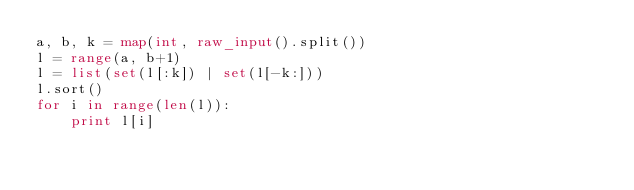<code> <loc_0><loc_0><loc_500><loc_500><_Python_>a, b, k = map(int, raw_input().split())
l = range(a, b+1)
l = list(set(l[:k]) | set(l[-k:]))
l.sort()
for i in range(len(l)):
	print l[i]</code> 